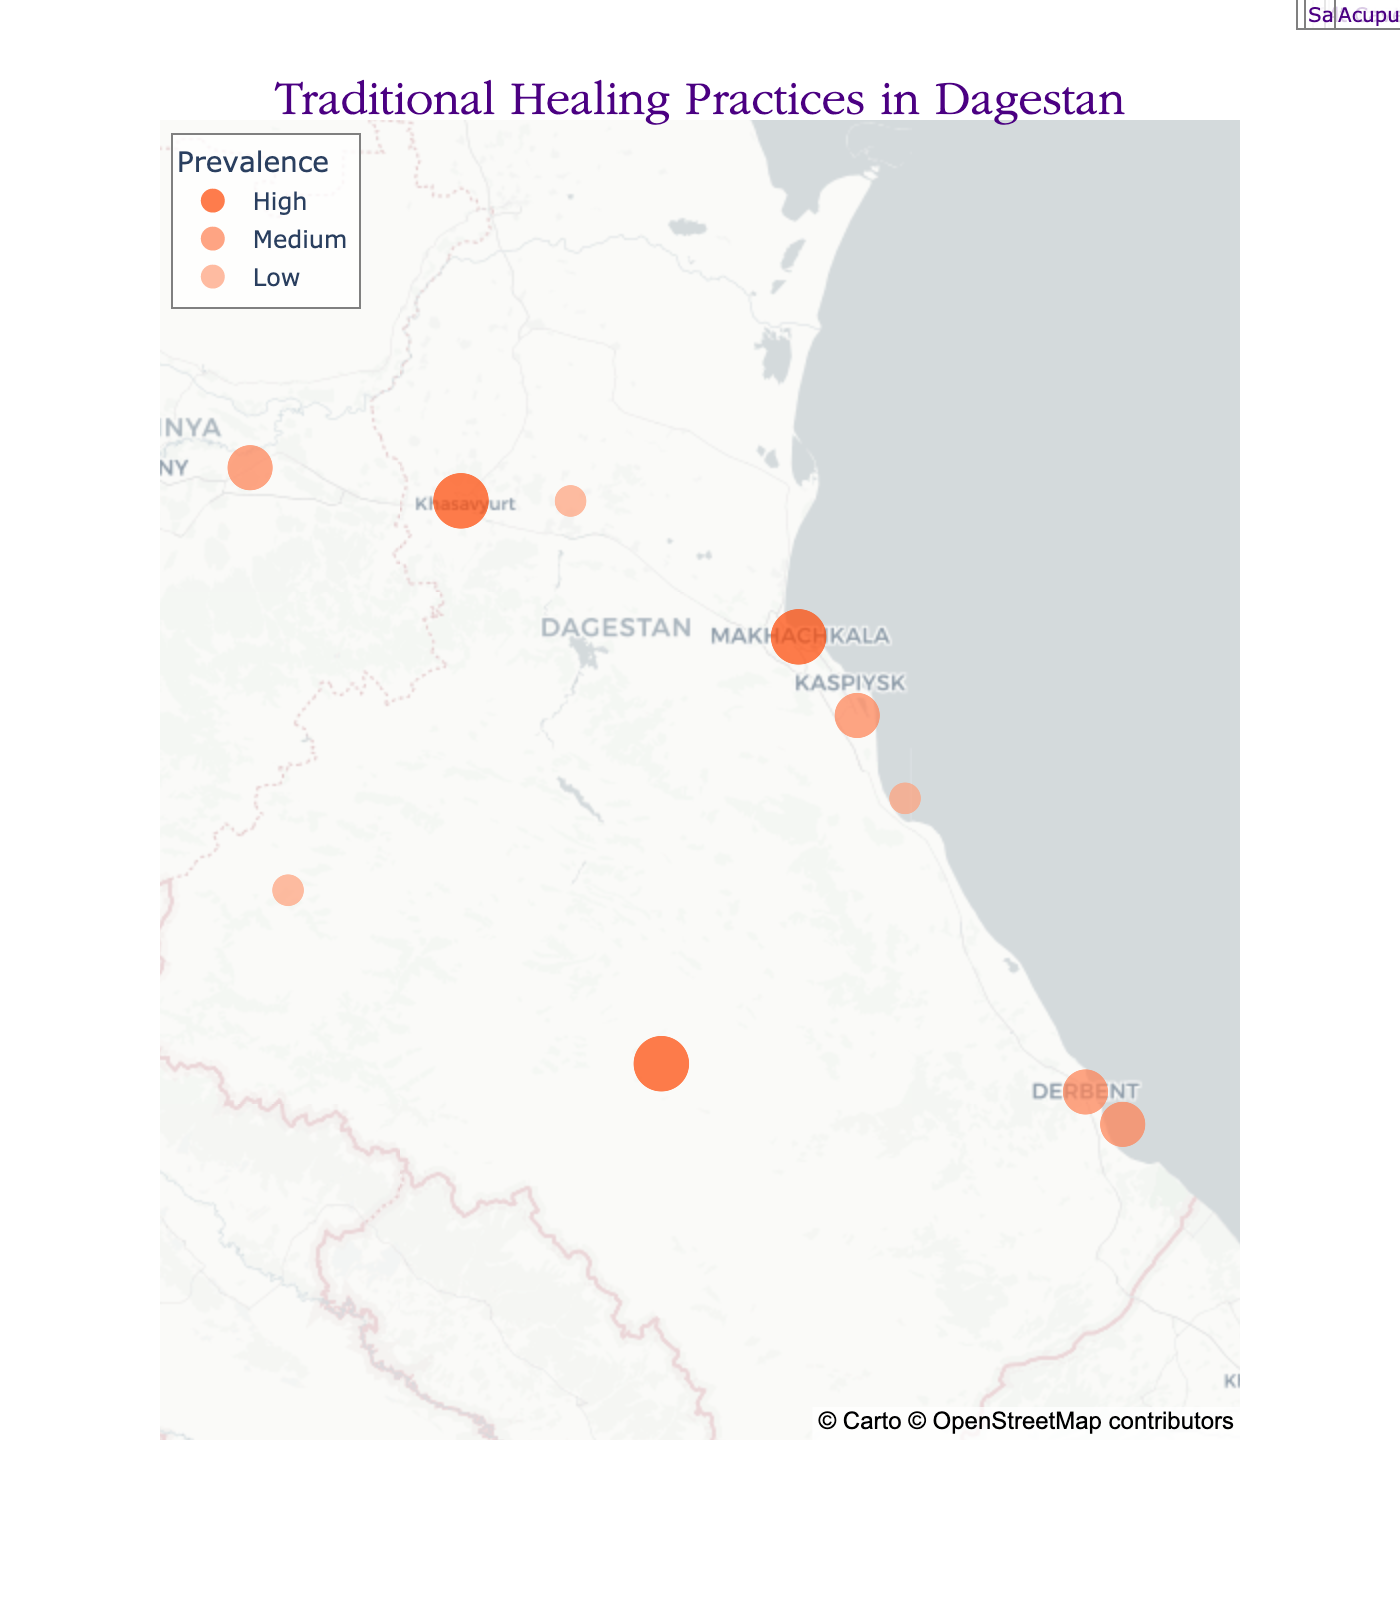What's the title of the figure? The title of the figure is usually found at the top of the plot. In this case, it's "Traditional Healing Practices in Dagestan" as mentioned within the code.
Answer: Traditional Healing Practices in Dagestan How many cities are shown on the map? The count of unique cities listed in the data can be seen on the plot as points on the geographic distribution. Counting them will give us the total. There are 10 cities: Makhachkala, Derbent, Khasavyurt, Buynaksk, Dagestanskiye Ogni, Izberbash, Kizlyar, Kizilyurt, Kaspiisk, and Kizilurt.
Answer: 10 Which city practices bone setting and what's its prevalence? By looking for the city with the traditional practice labeled "Bone Setting" in the plot, we notice Khasavyurt. The prevalence is marked as 'High', indicated by its visual size and color coding on the map.
Answer: Khasavyurt, High How do the prevalence levels of traditional practices compare between Buynaksk and Dagestanskiye Ogni? Referencing the respective points and color-coded prevalence on the map, Buynaksk has a 'Low' prevalence for Leech Therapy while Dagestanskiye Ogni has a 'Medium' prevalence for Apitherapy.
Answer: Buynaksk: Low, Dagestanskiye Ogni: Medium Which traditional practice is associated with Izberbash and what's its prevalence? By identifying the point corresponding to Izberbash and reading the hover information or annotation, Izberbash is associated with Mud Therapy and its prevalence is 'High'.
Answer: Mud Therapy, High What is the northernmost city on the map, and what traditional practice is associated with it? Examining the geographic distribution on the map, Kizlyar is the northernmost city. The associated traditional practice in Kizlyar is Hydrotherapy.
Answer: Kizlyar, Hydrotherapy Which cities have a 'Medium' prevalence of their traditional practices? Identifying the color-coded prevalence on the map, the cities with 'Medium' prevalence are Derbent (Cupping Therapy), Dagestanskiye Ogni (Apitherapy), Kizlyar (Hydrotherapy), and Kaspiisk (Salt Cave Therapy).
Answer: Derbent, Dagestanskiye Ogni, Kizlyar, Kaspiisk What is the westernmost city shown on the map? By viewing the geographic layout, the westernmost city is Kizilyurt. The traditional practice associated with Kizilyurt is Aromatherapy, and its prevalence is 'Low'.
Answer: Kizilyurt Which traditional healing practices are associated with 'High' prevalence and in which cities? By scanning the map for points marked with 'High' prevalence color coding, the traditional practices are Herbal Medicine in Makhachkala, Bone Setting in Khasavyurt, and Mud Therapy in Izberbash.
Answer: Herbal Medicine (Makhachkala), Bone Setting (Khasavyurt), Mud Therapy (Izberbash) Compare and contrast the prevalence of traditional practices between Makhachkala and Kaspiisk. Makhachkala has a 'High' prevalence for Herbal Medicine, indicated by a larger point size and darker color on the map, while Kaspiisk has a 'Medium' prevalence for Salt Cave Therapy, shown by a medium point size and lighter color.
Answer: Makhachkala: High, Kaspiisk: Medium 